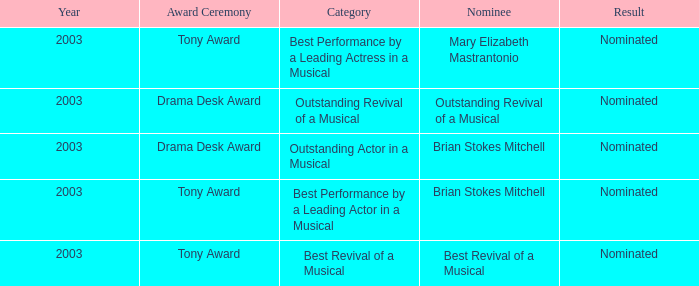What year was Mary Elizabeth Mastrantonio nominated? 2003.0. 